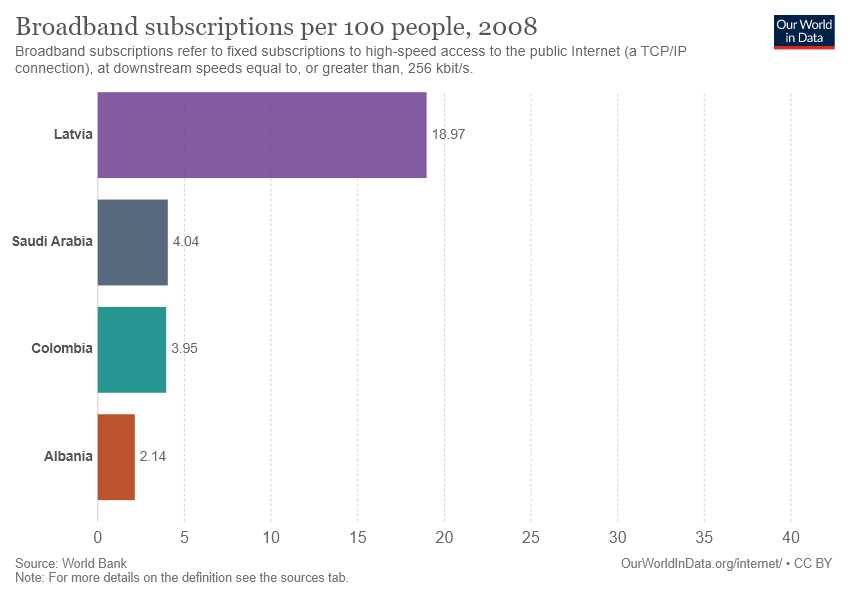Give some essential details in this illustration. Saudi Arabia is greater than Albania by 1.88785... What is Colombia data? 3.95..." is not a complete sentence and is not clear what is being asked. Can you please provide more context or specify what you would like to know? 